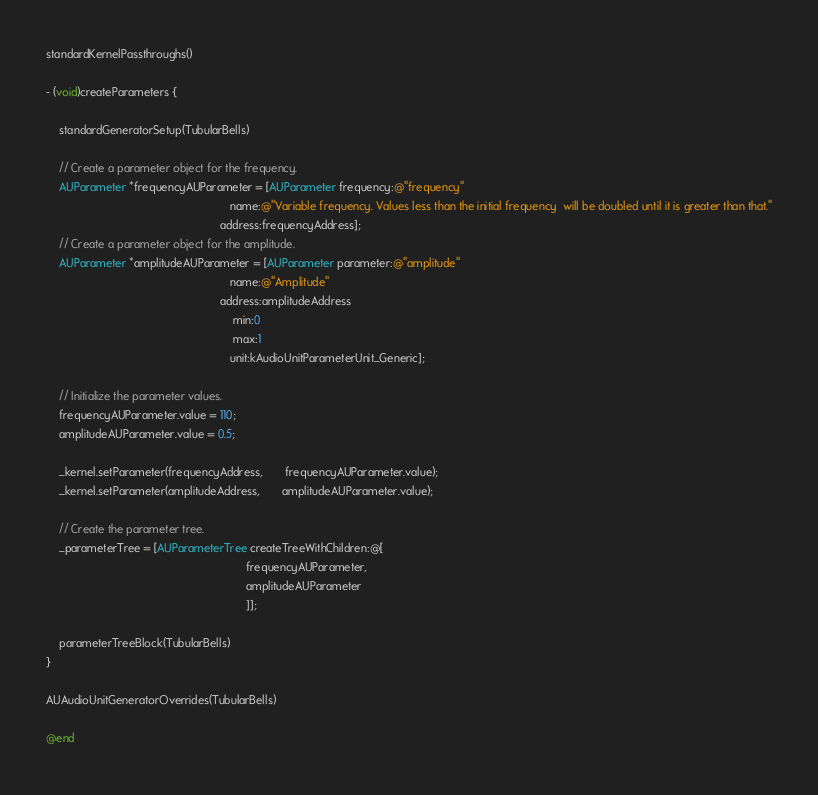Convert code to text. <code><loc_0><loc_0><loc_500><loc_500><_ObjectiveC_>standardKernelPassthroughs()

- (void)createParameters {
    
    standardGeneratorSetup(TubularBells)
    
    // Create a parameter object for the frequency.
    AUParameter *frequencyAUParameter = [AUParameter frequency:@"frequency"
                                                          name:@"Variable frequency. Values less than the initial frequency  will be doubled until it is greater than that."
                                                       address:frequencyAddress];
    // Create a parameter object for the amplitude.
    AUParameter *amplitudeAUParameter = [AUParameter parameter:@"amplitude"
                                                          name:@"Amplitude"
                                                       address:amplitudeAddress
                                                           min:0
                                                           max:1
                                                          unit:kAudioUnitParameterUnit_Generic];
    
    // Initialize the parameter values.
    frequencyAUParameter.value = 110;
    amplitudeAUParameter.value = 0.5;
    
    _kernel.setParameter(frequencyAddress,       frequencyAUParameter.value);
    _kernel.setParameter(amplitudeAddress,       amplitudeAUParameter.value);
    
    // Create the parameter tree.
    _parameterTree = [AUParameterTree createTreeWithChildren:@[
                                                               frequencyAUParameter,
                                                               amplitudeAUParameter
                                                               ]];
    
    parameterTreeBlock(TubularBells)
}

AUAudioUnitGeneratorOverrides(TubularBells)

@end


</code> 